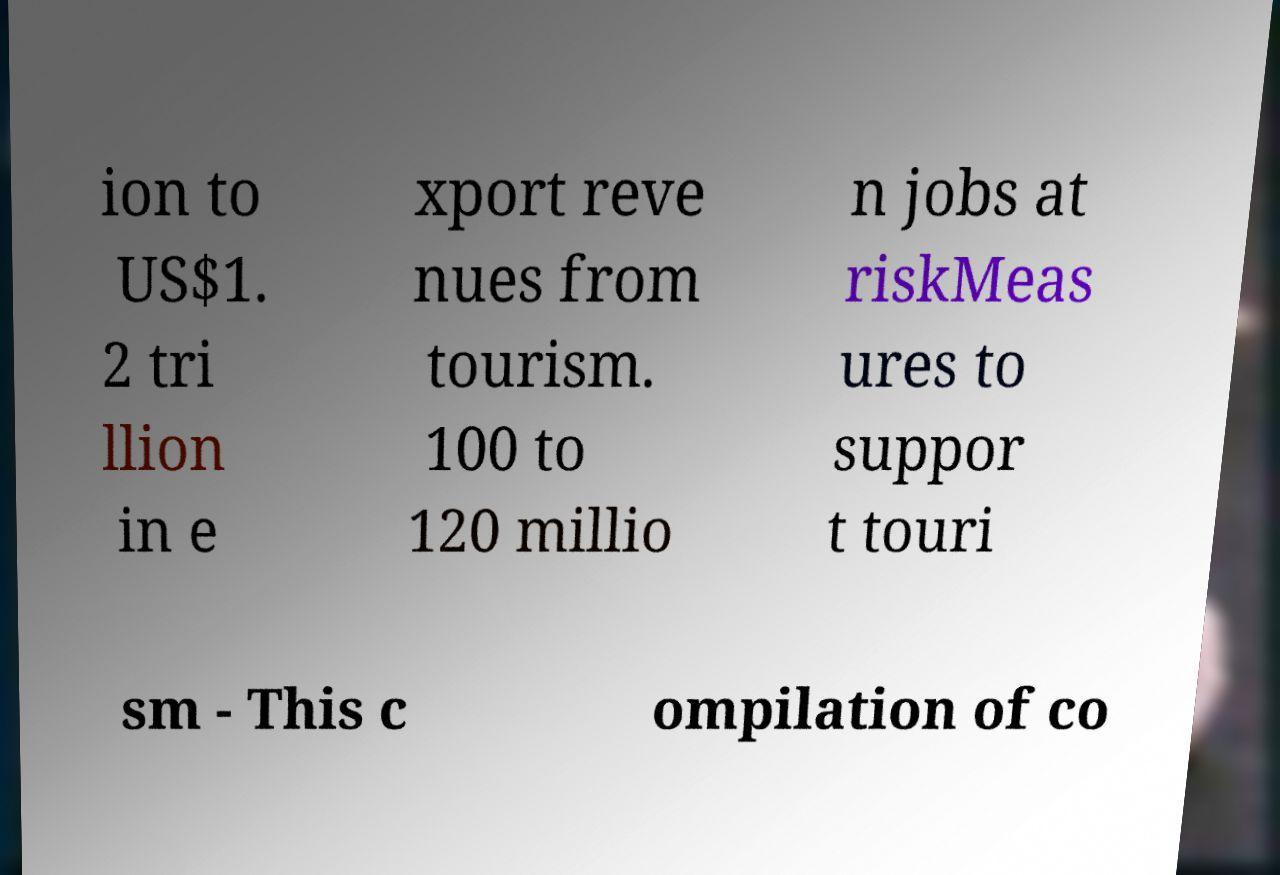Please identify and transcribe the text found in this image. ion to US$1. 2 tri llion in e xport reve nues from tourism. 100 to 120 millio n jobs at riskMeas ures to suppor t touri sm - This c ompilation of co 